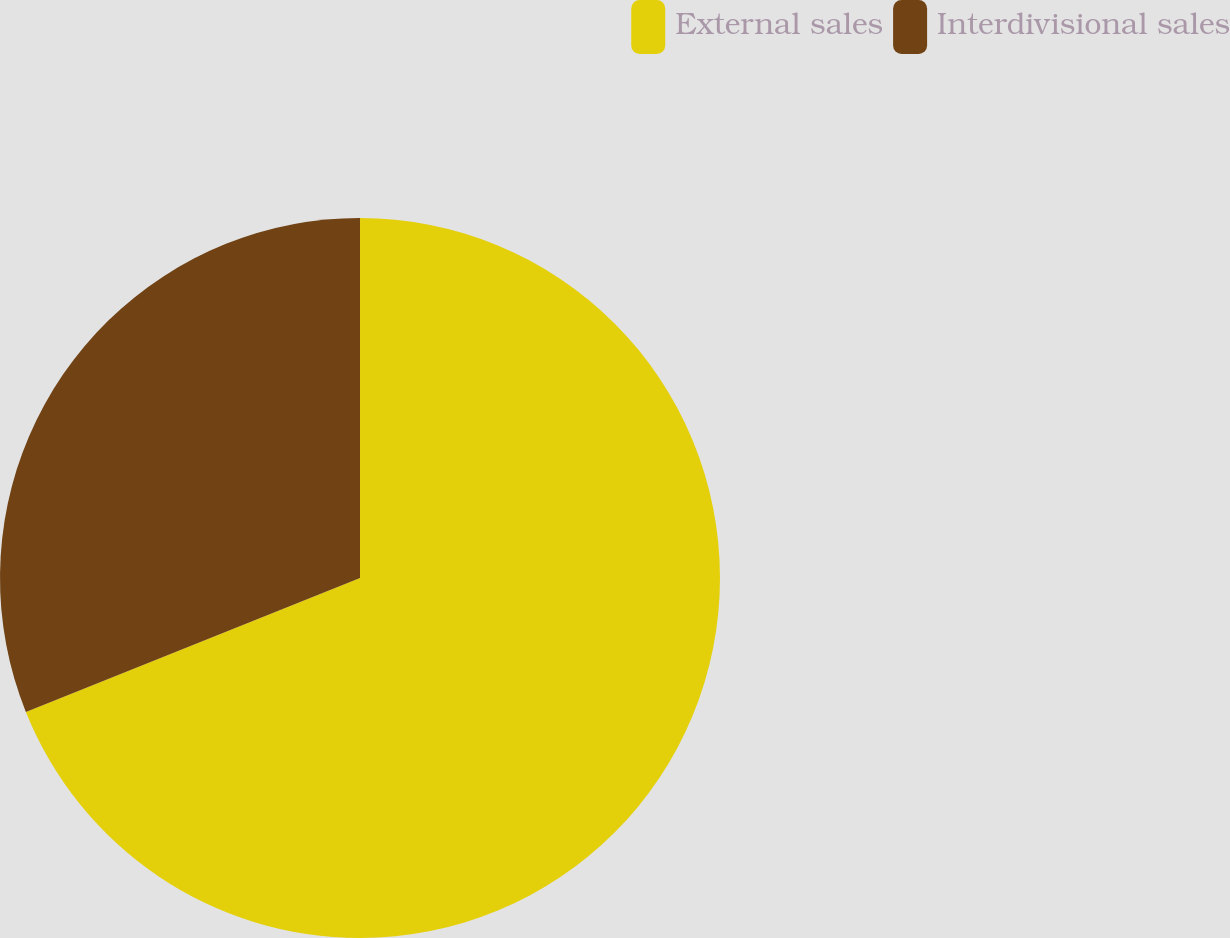<chart> <loc_0><loc_0><loc_500><loc_500><pie_chart><fcel>External sales<fcel>Interdivisional sales<nl><fcel>68.93%<fcel>31.07%<nl></chart> 